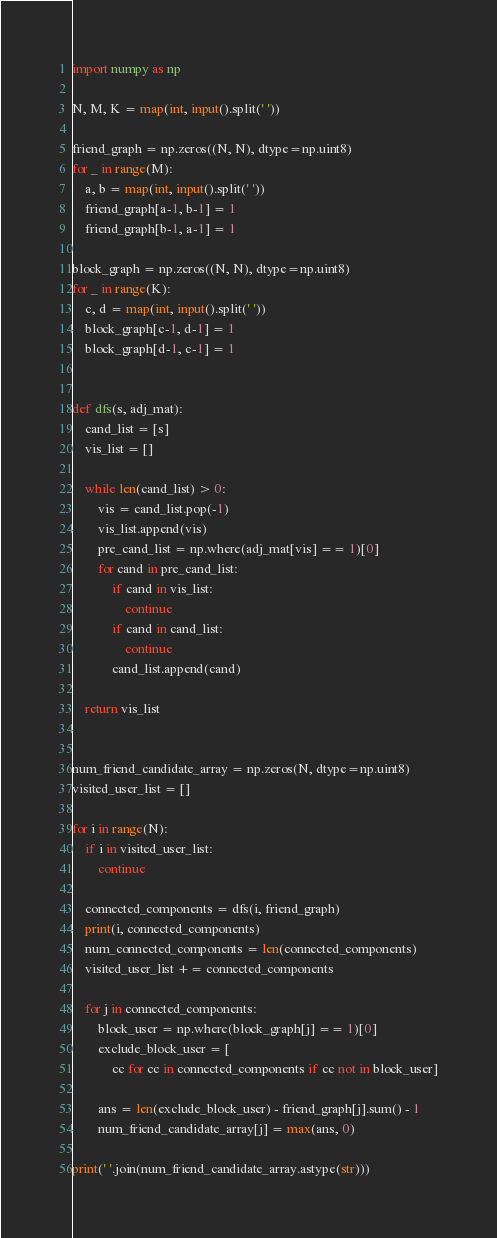<code> <loc_0><loc_0><loc_500><loc_500><_Python_>import numpy as np

N, M, K = map(int, input().split(' '))

friend_graph = np.zeros((N, N), dtype=np.uint8)
for _ in range(M):
    a, b = map(int, input().split(' '))
    friend_graph[a-1, b-1] = 1
    friend_graph[b-1, a-1] = 1

block_graph = np.zeros((N, N), dtype=np.uint8)
for _ in range(K):
    c, d = map(int, input().split(' '))
    block_graph[c-1, d-1] = 1
    block_graph[d-1, c-1] = 1


def dfs(s, adj_mat):
    cand_list = [s]
    vis_list = []

    while len(cand_list) > 0:
        vis = cand_list.pop(-1)
        vis_list.append(vis)
        pre_cand_list = np.where(adj_mat[vis] == 1)[0]
        for cand in pre_cand_list:
            if cand in vis_list:
                continue
            if cand in cand_list:
                continue
            cand_list.append(cand)

    return vis_list


num_friend_candidate_array = np.zeros(N, dtype=np.uint8)
visited_user_list = []

for i in range(N):
    if i in visited_user_list:
        continue

    connected_components = dfs(i, friend_graph)
    print(i, connected_components)
    num_connected_components = len(connected_components)
    visited_user_list += connected_components

    for j in connected_components:
        block_user = np.where(block_graph[j] == 1)[0]
        exclude_block_user = [
            cc for cc in connected_components if cc not in block_user]

        ans = len(exclude_block_user) - friend_graph[j].sum() - 1
        num_friend_candidate_array[j] = max(ans, 0)

print(' '.join(num_friend_candidate_array.astype(str)))
</code> 